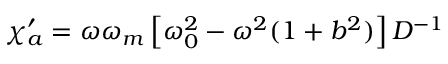Convert formula to latex. <formula><loc_0><loc_0><loc_500><loc_500>\chi _ { a } ^ { \prime } = \omega \omega _ { m } \left [ \omega _ { 0 } ^ { 2 } - \omega ^ { 2 } ( 1 + b ^ { 2 } ) \right ] D ^ { - 1 }</formula> 